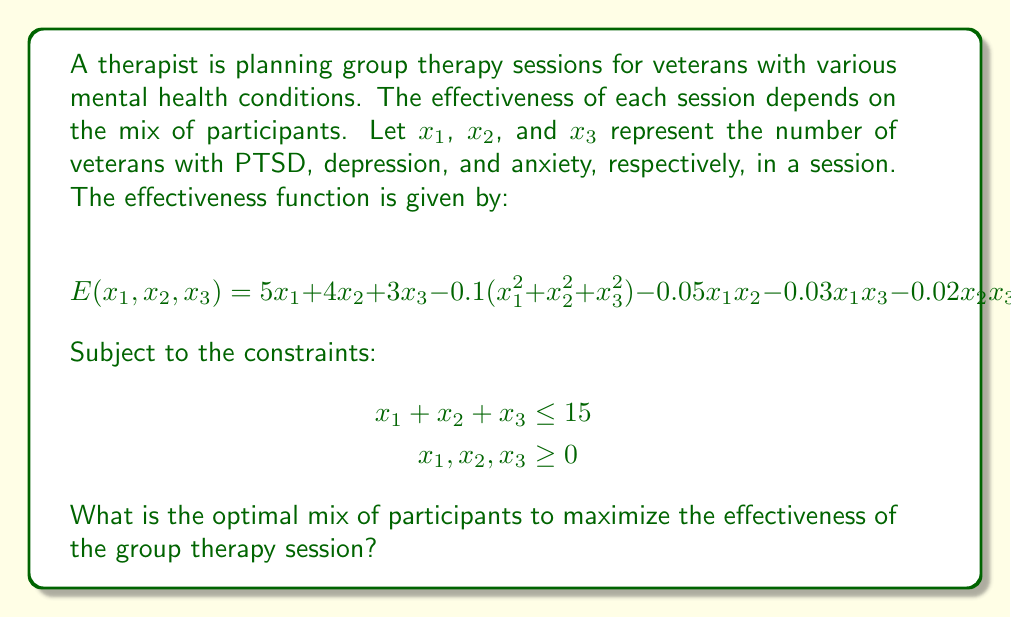Solve this math problem. To solve this optimization problem, we'll use the method of Lagrange multipliers:

1) First, we form the Lagrangian function:
   $$L = 5x_1 + 4x_2 + 3x_3 - 0.1(x_1^2 + x_2^2 + x_3^2) - 0.05x_1x_2 - 0.03x_1x_3 - 0.02x_2x_3 - \lambda(x_1 + x_2 + x_3 - 15)$$

2) We then take partial derivatives and set them equal to zero:
   $$\frac{\partial L}{\partial x_1} = 5 - 0.2x_1 - 0.05x_2 - 0.03x_3 - \lambda = 0$$
   $$\frac{\partial L}{\partial x_2} = 4 - 0.2x_2 - 0.05x_1 - 0.02x_3 - \lambda = 0$$
   $$\frac{\partial L}{\partial x_3} = 3 - 0.2x_3 - 0.03x_1 - 0.02x_2 - \lambda = 0$$
   $$\frac{\partial L}{\partial \lambda} = x_1 + x_2 + x_3 - 15 = 0$$

3) Solving this system of equations:
   From the first three equations:
   $$5 - 0.2x_1 - 0.05x_2 - 0.03x_3 = 4 - 0.2x_2 - 0.05x_1 - 0.02x_3 = 3 - 0.2x_3 - 0.03x_1 - 0.02x_2$$

4) After some algebraic manipulation and substitution, we get:
   $$x_1 \approx 7.14, x_2 \approx 5.36, x_3 \approx 2.50$$

5) Rounding to the nearest integer (as we can't have fractional participants):
   $$x_1 = 7, x_2 = 5, x_3 = 3$$

6) We verify that this solution satisfies the constraints:
   $$7 + 5 + 3 = 15 \leq 15$$
   $$7, 5, 3 \geq 0$$

Therefore, the optimal mix is 7 veterans with PTSD, 5 with depression, and 3 with anxiety.
Answer: The optimal mix to maximize the effectiveness of the group therapy session is 7 veterans with PTSD, 5 with depression, and 3 with anxiety. 